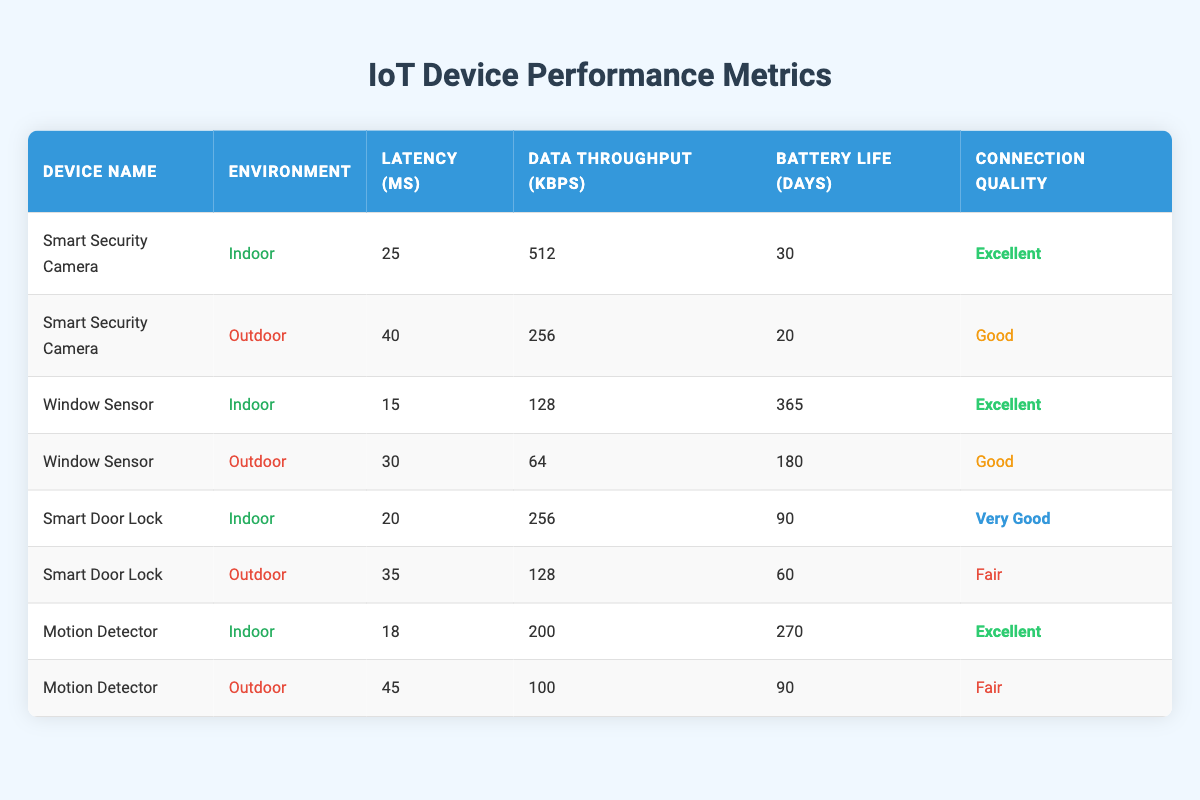What is the latency of the Smart Security Camera in indoor environments? The table shows the performance metrics of the Smart Security Camera for indoor settings, where "Latency (ms)" is listed as 25.
Answer: 25 ms How many days of battery life does the Window Sensor have in indoor environments? According to the table, the Window Sensor in an indoor environment has "Battery Life (days)" listed as 365.
Answer: 365 days What is the average latency of the Motion Detector across both indoor and outdoor environments? The latency for the Motion Detector is 18 ms (indoor) and 45 ms (outdoor). To find the average, sum these values (18 + 45 = 63) and divide by 2 (63/2 = 31.5).
Answer: 31.5 ms Which device has the best connection quality in an outdoor environment? Examining the table, the Smart Security Camera shows "Connection Quality" as Good, and the Motion Detector and Smart Door Lock show Fair. Therefore, the Smart Security Camera has the best connection quality for outdoor use.
Answer: Smart Security Camera Is the data throughput of the Smart Door Lock in an indoor environment greater than its outdoor throughput? In the table, for the Smart Door Lock, the indoor "Data Throughput (kbps)" is 256, while the outdoor is 128. Since 256 is greater than 128, this statement is true.
Answer: Yes What is the latency difference between indoor and outdoor environments for the Window Sensor? The latency for the Window Sensor is 15 ms indoor and 30 ms outdoor. To determine the difference, calculate 30 - 15 = 15 ms.
Answer: 15 ms Which device has the longest battery life in an outdoor environment? The table shows that the Window Sensor has a battery life of 180 days outdoors, Smart Door Lock has 60 days, and the Motion Detector has 90 days. Thus, the Window Sensor has the longest battery life.
Answer: Window Sensor How many devices have excellent connection quality indoors? Based on the table, the devices with excellent connection quality indoors are Smart Security Camera, Window Sensor, and Motion Detector. This totals three devices.
Answer: 3 devices What is the total data throughput of all devices in indoor environments? Summing the data throughput for indoor devices: 512 (Smart Security Camera) + 128 (Window Sensor) + 256 (Smart Door Lock) + 200 (Motion Detector) = 1096 kbps.
Answer: 1096 kbps 